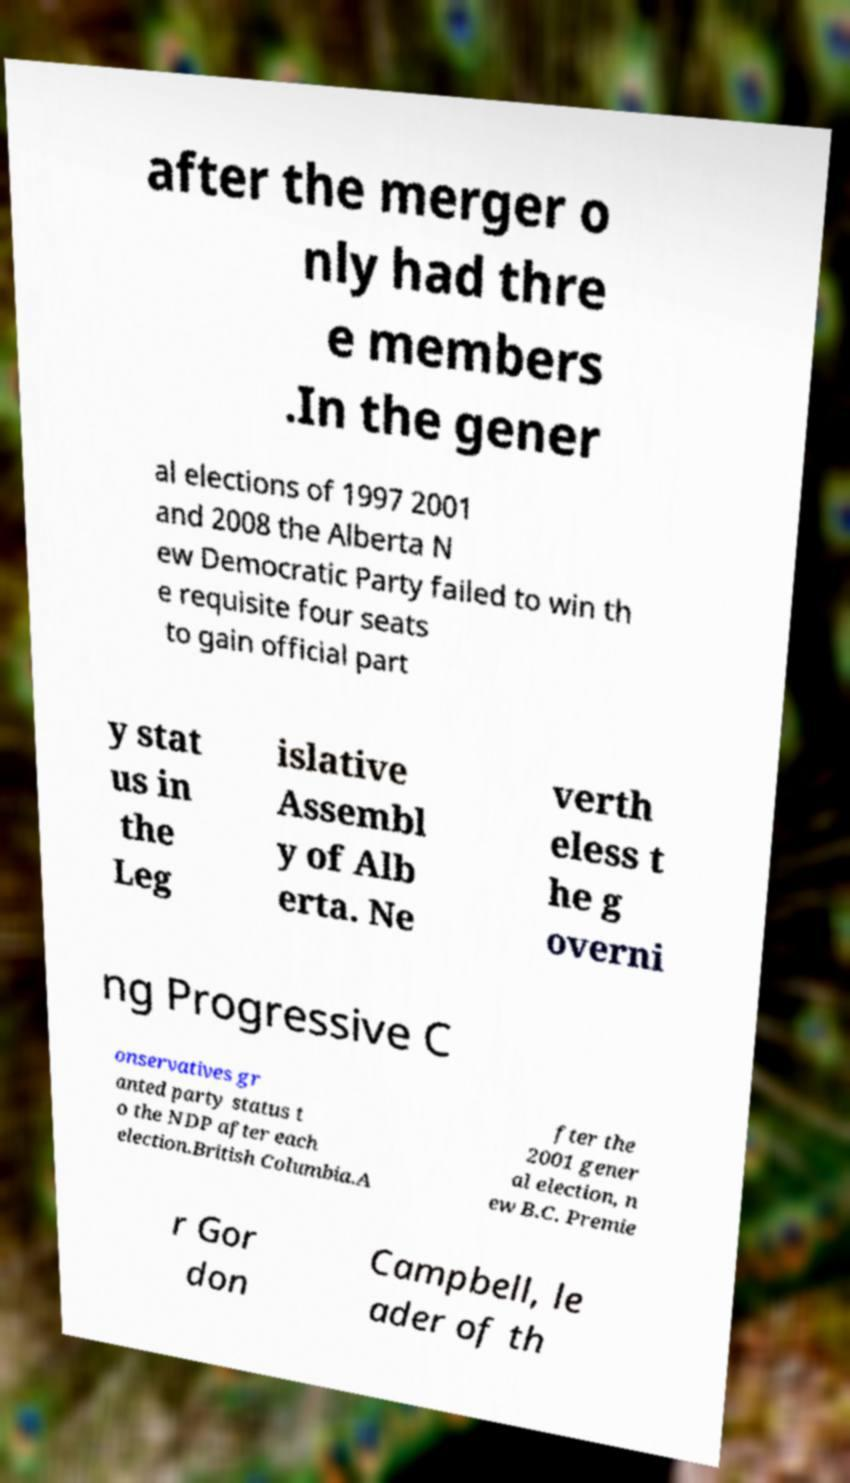Could you extract and type out the text from this image? after the merger o nly had thre e members .In the gener al elections of 1997 2001 and 2008 the Alberta N ew Democratic Party failed to win th e requisite four seats to gain official part y stat us in the Leg islative Assembl y of Alb erta. Ne verth eless t he g overni ng Progressive C onservatives gr anted party status t o the NDP after each election.British Columbia.A fter the 2001 gener al election, n ew B.C. Premie r Gor don Campbell, le ader of th 